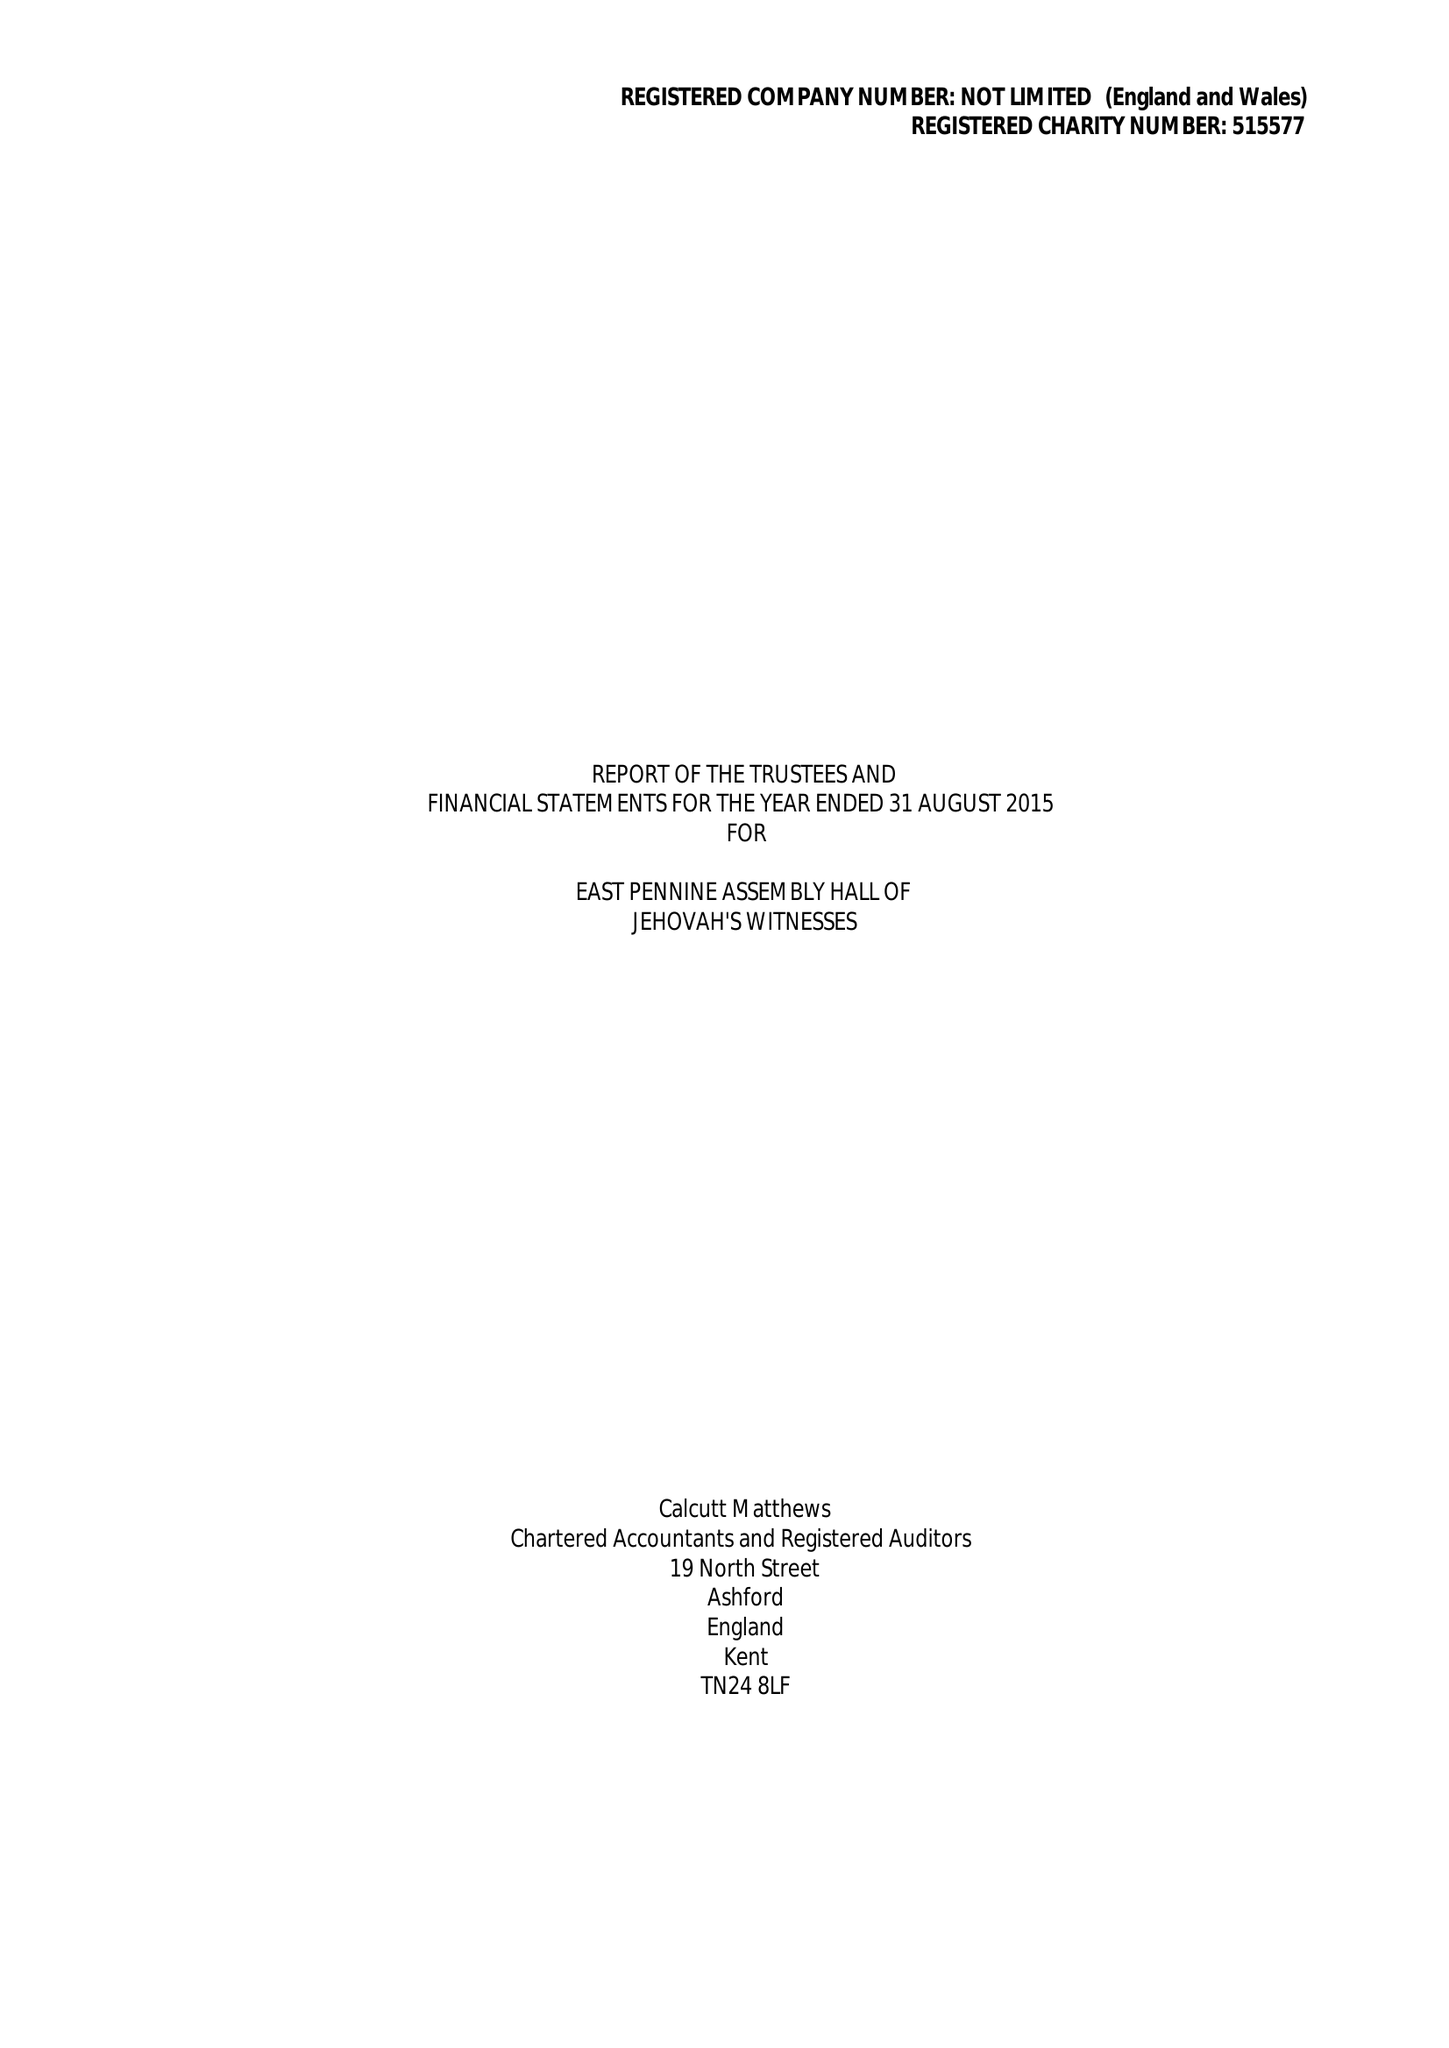What is the value for the address__street_line?
Answer the question using a single word or phrase. FRETWELL ROAD 